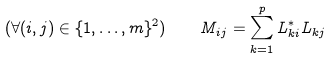Convert formula to latex. <formula><loc_0><loc_0><loc_500><loc_500>( \forall ( i , j ) \in \{ 1 , \dots , m \} ^ { 2 } ) \quad M _ { i j } = \sum _ { k = 1 } ^ { p } L _ { k i } ^ { * } L _ { k j }</formula> 